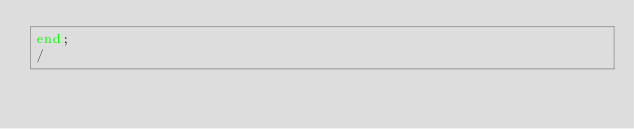Convert code to text. <code><loc_0><loc_0><loc_500><loc_500><_SQL_>end;
/
</code> 